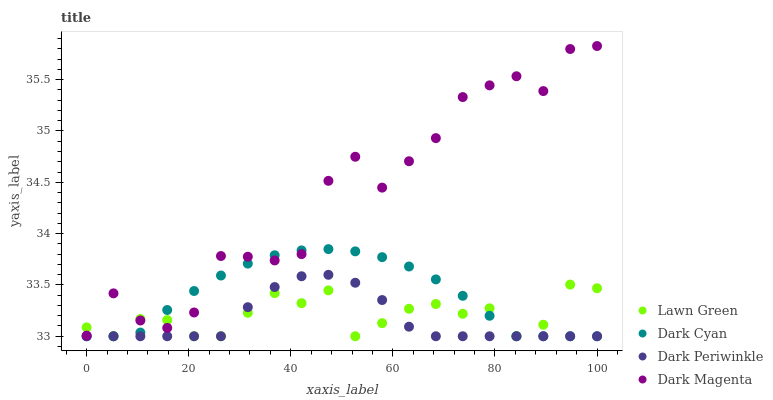Does Dark Periwinkle have the minimum area under the curve?
Answer yes or no. Yes. Does Dark Magenta have the maximum area under the curve?
Answer yes or no. Yes. Does Lawn Green have the minimum area under the curve?
Answer yes or no. No. Does Lawn Green have the maximum area under the curve?
Answer yes or no. No. Is Dark Cyan the smoothest?
Answer yes or no. Yes. Is Dark Magenta the roughest?
Answer yes or no. Yes. Is Lawn Green the smoothest?
Answer yes or no. No. Is Lawn Green the roughest?
Answer yes or no. No. Does Dark Cyan have the lowest value?
Answer yes or no. Yes. Does Dark Magenta have the lowest value?
Answer yes or no. No. Does Dark Magenta have the highest value?
Answer yes or no. Yes. Does Dark Periwinkle have the highest value?
Answer yes or no. No. Is Dark Periwinkle less than Dark Magenta?
Answer yes or no. Yes. Is Dark Magenta greater than Dark Periwinkle?
Answer yes or no. Yes. Does Dark Cyan intersect Lawn Green?
Answer yes or no. Yes. Is Dark Cyan less than Lawn Green?
Answer yes or no. No. Is Dark Cyan greater than Lawn Green?
Answer yes or no. No. Does Dark Periwinkle intersect Dark Magenta?
Answer yes or no. No. 